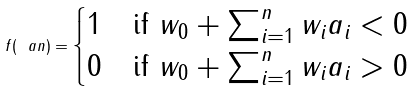<formula> <loc_0><loc_0><loc_500><loc_500>f ( \ a n ) = \begin{cases} 1 & \text {if} \ w _ { 0 } + \sum _ { i = 1 } ^ { n } w _ { i } a _ { i } < 0 \\ 0 & \text {if} \ w _ { 0 } + \sum _ { i = 1 } ^ { n } w _ { i } a _ { i } > 0 \\ \end{cases}</formula> 